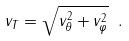<formula> <loc_0><loc_0><loc_500><loc_500>v _ { T } = \sqrt { v _ { \theta } ^ { 2 } + v _ { \varphi } ^ { 2 } } \ .</formula> 